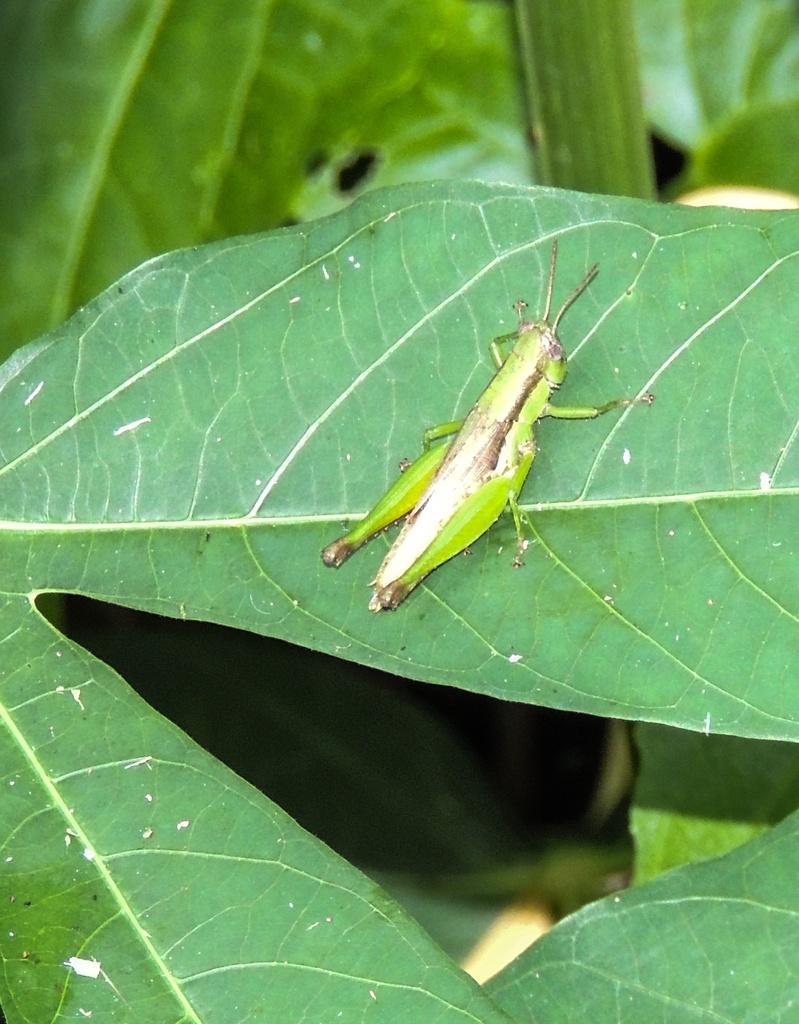Can you describe this image briefly? In this picture there is a grasshopper on the leaf. There are leaves on the plant. 